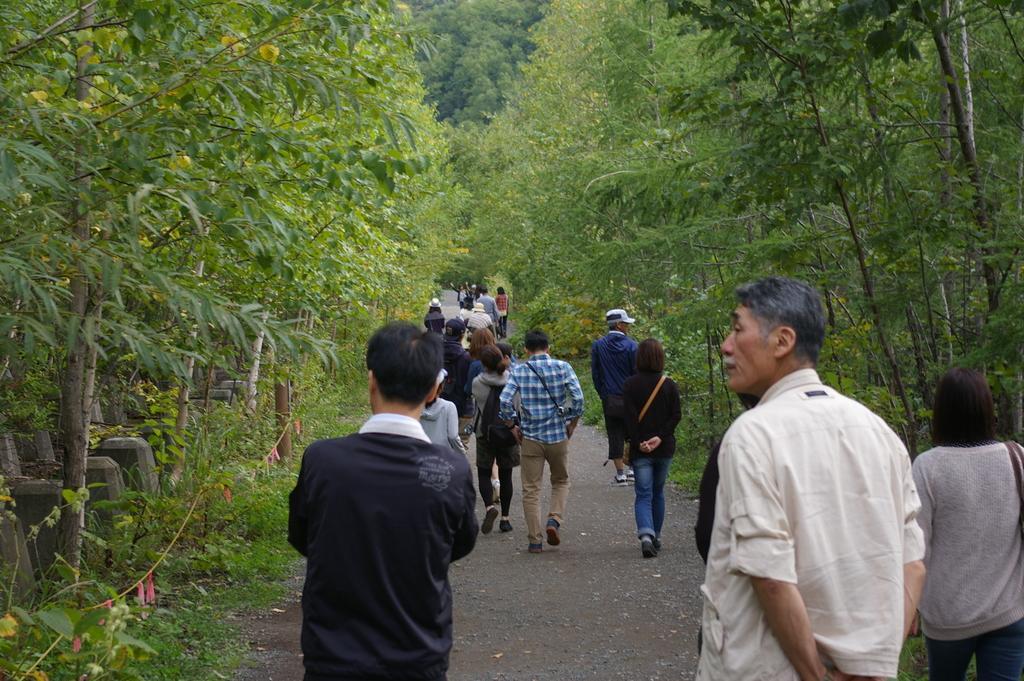How would you summarize this image in a sentence or two? In this image there are few people walking on the path. On the either sides of the road and in the background there are trees. 